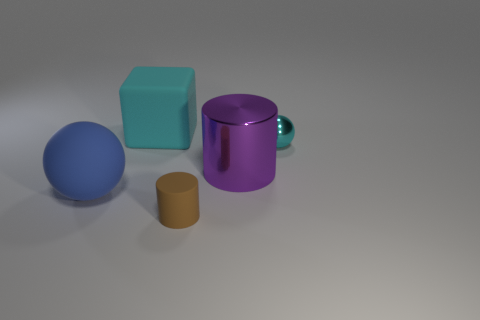Add 3 big red things. How many objects exist? 8 Subtract all spheres. How many objects are left? 3 Subtract all cyan things. Subtract all yellow objects. How many objects are left? 3 Add 3 large purple cylinders. How many large purple cylinders are left? 4 Add 4 large brown rubber cylinders. How many large brown rubber cylinders exist? 4 Subtract 0 brown blocks. How many objects are left? 5 